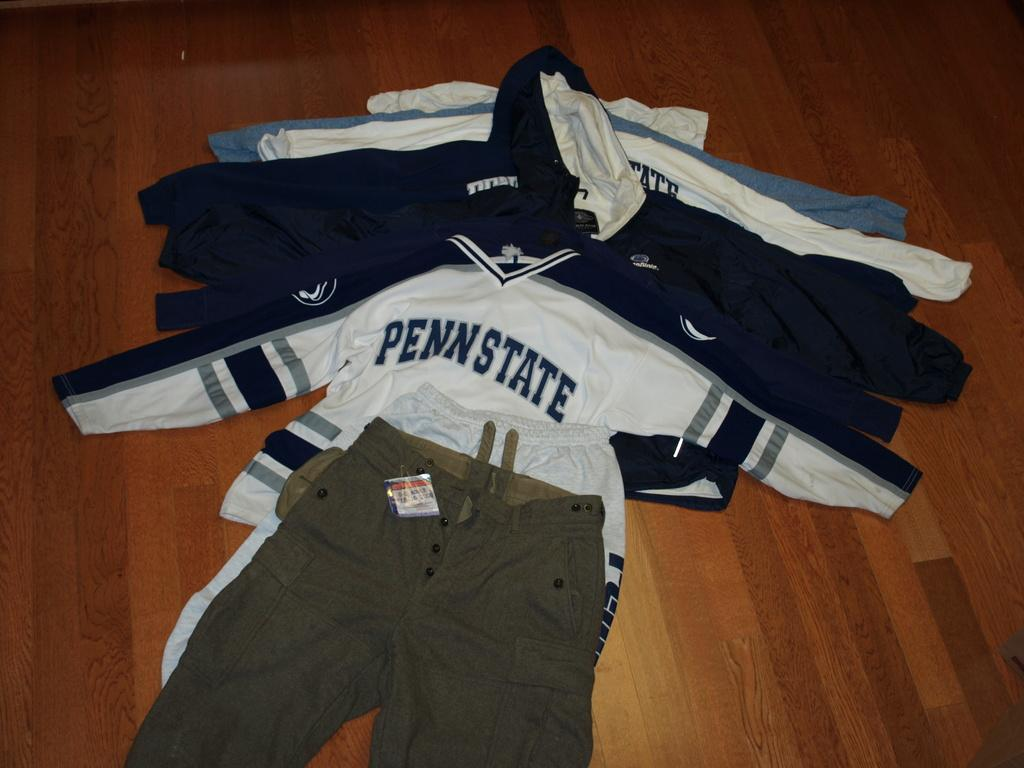<image>
Create a compact narrative representing the image presented. clothes on the ground include a Penn State jersey 